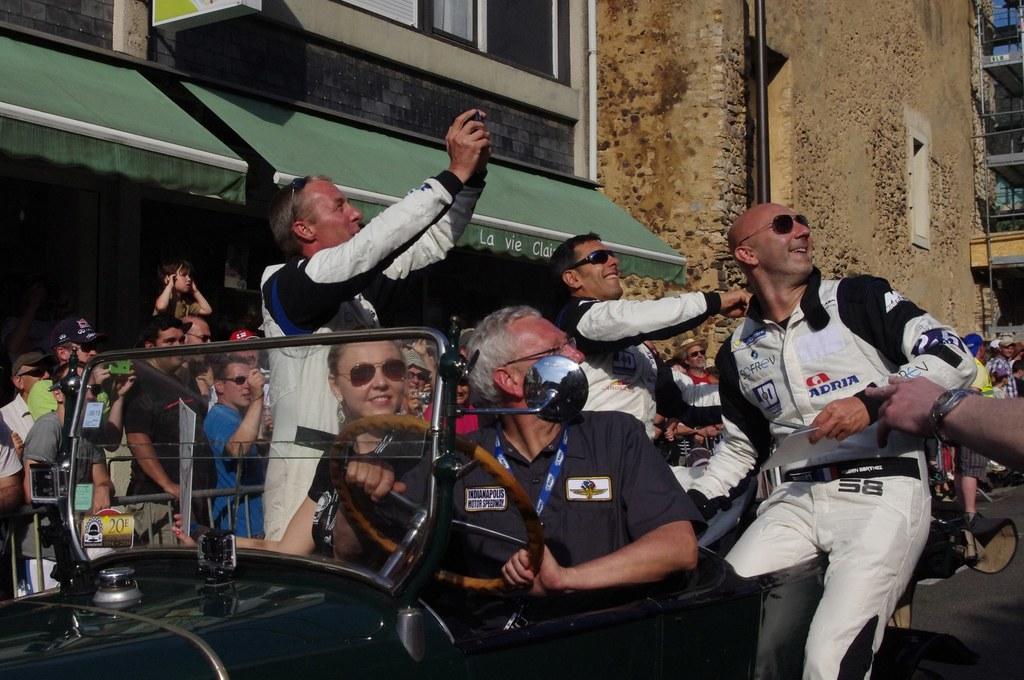In one or two sentences, can you explain what this image depicts? In the image we can see a vehicle on the road, in the vehicle there are people sitting, they are wearing clothes and some of them are wearing spectacles. There are even people standing, this is a wrist watch, gadget, building, pipe and window of the building. 